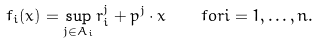Convert formula to latex. <formula><loc_0><loc_0><loc_500><loc_500>f _ { i } ( x ) = \sup _ { j \in A _ { i } } r ^ { j } _ { i } + p ^ { j } \cdot x \quad f o r i = 1 , \dots , n .</formula> 